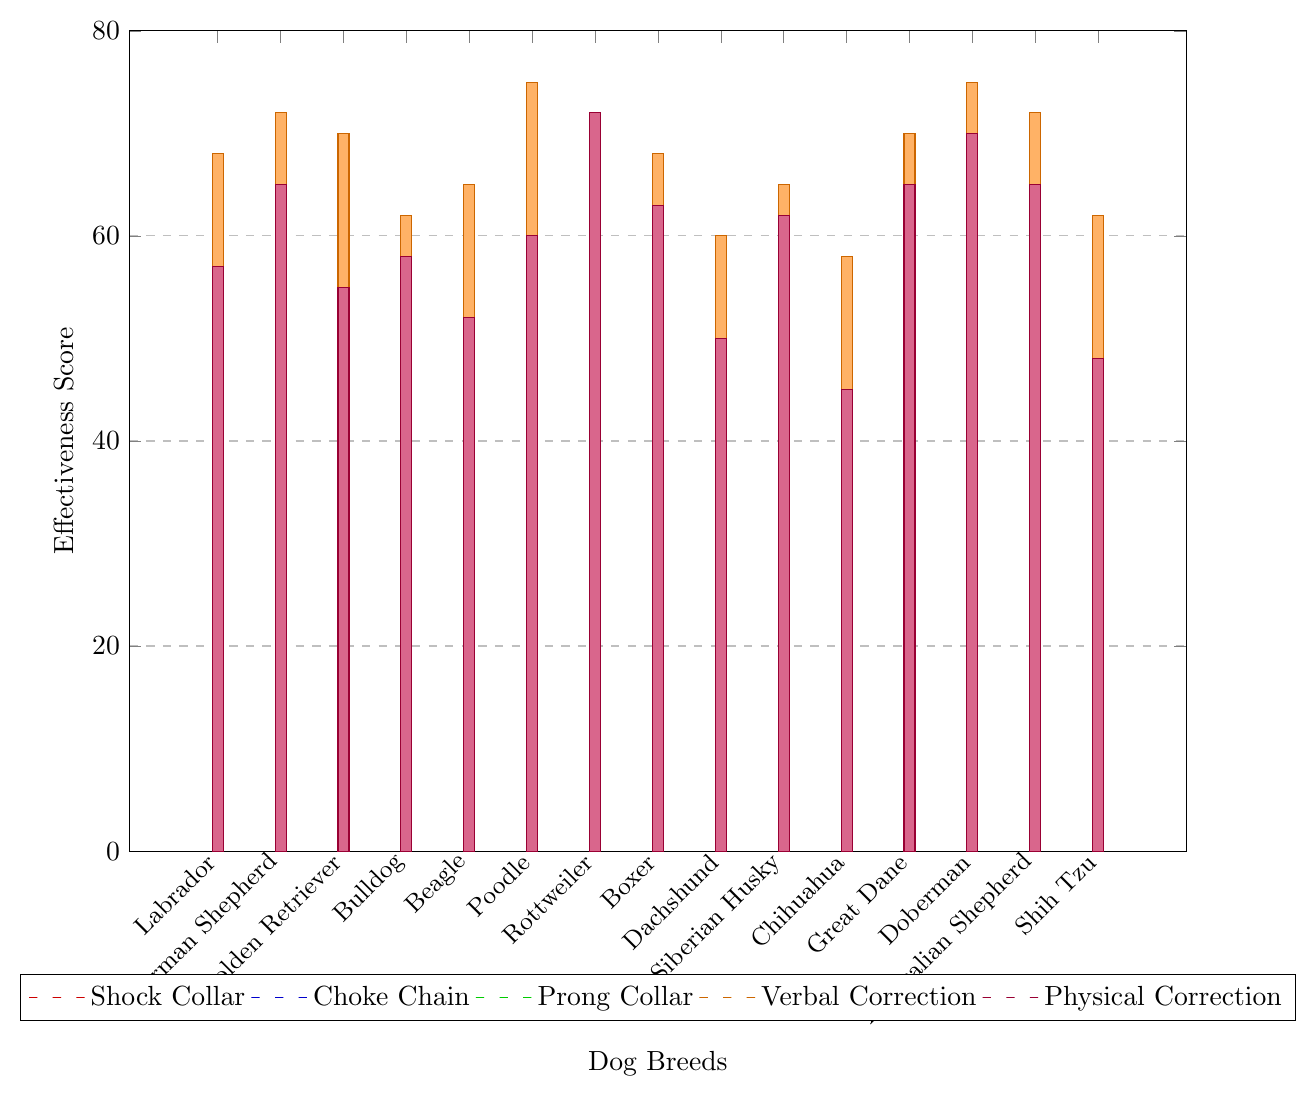What's the highest effectiveness score for Shock Collar training among all breeds? To find the highest effectiveness score for Shock Collar training, look at the red bars in the chart. The highest bar among the red ones corresponds to the Rottweiler with a score of 62.
Answer: 62 Which breed shows the lowest effectiveness score for Prong Collar training? Look at the green bars for Prong Collar training and identify the shortest one. The Chihuahua has the lowest score in this category with a score of 32.
Answer: Chihuahua What's the average effectiveness score of Verbal Correction for Labrador Retriever, German Shepherd, and Golden Retriever? Verbal Correction scores for these breeds are 68, 72, and 70 respectively. Calculate the average by summing them up (68 + 72 + 70 = 210) and dividing by 3, which gives 210 / 3 = 70.
Answer: 70 Compare the effectiveness of Physical Correction in Rottweilers and Doberman Pinschers. Which breed shows higher effectiveness? Look at the purple bars for Physical Correction for both breeds: Rottweilers have a score of 72, and Doberman Pinschers have a score of 70. 72 is greater than 70, so Rottweilers show higher effectiveness.
Answer: Rottweiler Identify the breed with the most uniform (least varied) effectiveness scores across all training methods. By observing the heights of the bars for each breed, compare how varied they are. The Australian Shepherd appears to have the most uniform effectiveness scores across different methods, with values being relatively close to each other.
Answer: Australian Shepherd What's the total effectiveness score for Beagle across all training methods? Sum the effectiveness scores for Beagle: Shock Collar (38) + Choke Chain (45) + Prong Collar (42) + Verbal Correction (65) + Physical Correction (52). The total score is 38 + 45 + 42 + 65 + 52 = 242.
Answer: 242 Which training method shows the highest effectiveness for the largest number of breeds? To find this, visually compare the heights of bars for each method across all breeds. Verbal Correction (orange bars) generally appears to be the highest among most breeds.
Answer: Verbal Correction What is the difference in effectiveness of Physical Correction between Great Dane and Chihuahua? Refer to the purple bars for both breeds: Great Dane has a score of 65 and Chihuahua has a score of 45. Subtract the two values to find the difference: 65 - 45 = 20.
Answer: 20 Which method shows the least effectiveness for Golden Retriever? For Golden Retriever, compare the heights of the bars: Shock Collar (42), Choke Chain (50), Prong Collar (46), Verbal Correction (70), and Physical Correction (55). The Shock Collar method has the lowest score of 42.
Answer: Shock Collar What's the average effectiveness score of Physical Correction across all breeds? Sum all the effectiveness scores for Physical Correction: 57 + 65 + 55 + 58 + 52 + 60 + 72 + 63 + 50 + 62 + 45 + 65 + 70 + 65 + 48 = 887. Divide by the number of breeds (15) to get the average: 887 / 15 ≈ 59.13.
Answer: 59.13 